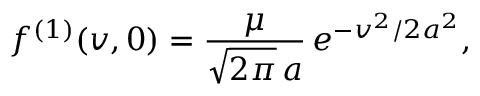<formula> <loc_0><loc_0><loc_500><loc_500>f ^ { ( 1 ) } ( v , 0 ) = \frac { \mu } { \sqrt { 2 \pi } \, a } \, e ^ { - v ^ { 2 } / 2 a ^ { 2 } } ,</formula> 